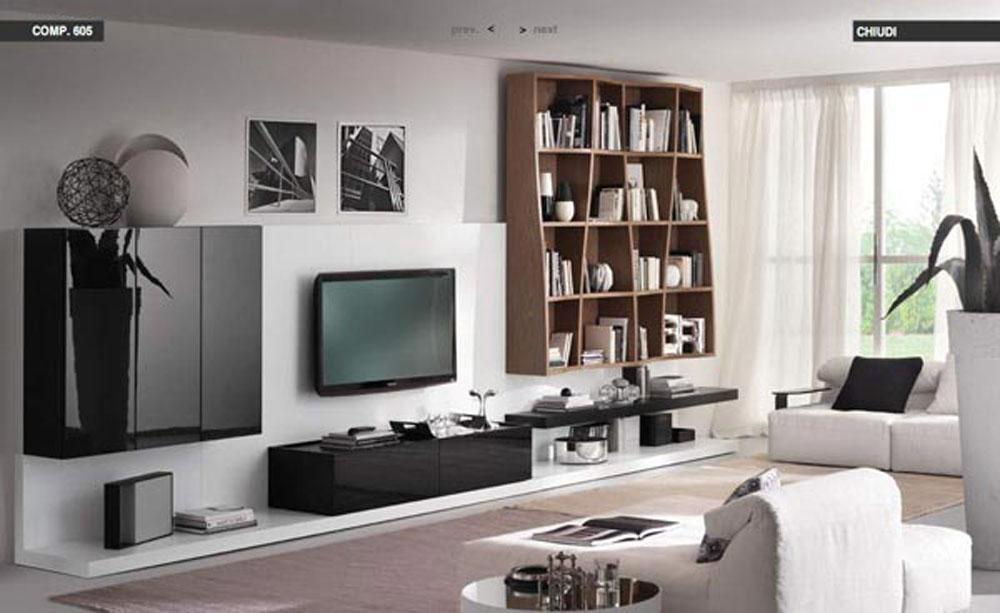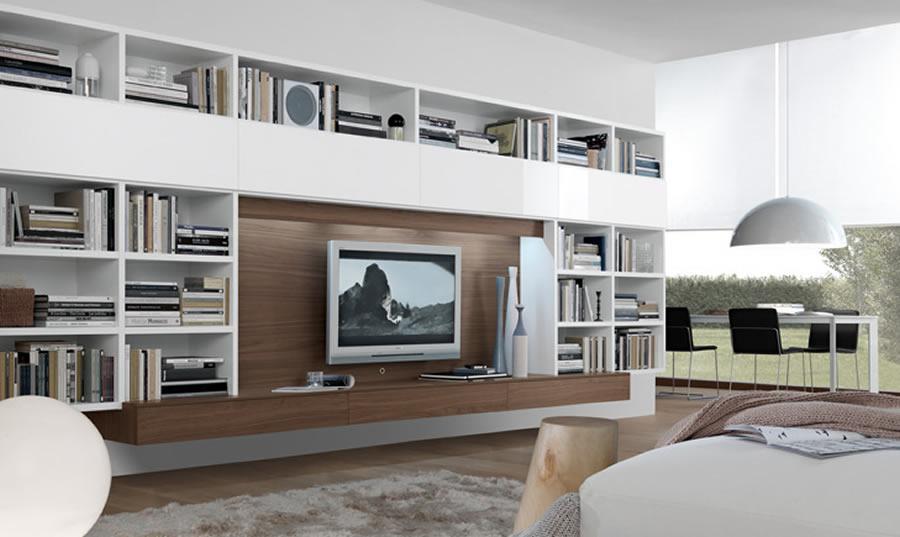The first image is the image on the left, the second image is the image on the right. Analyze the images presented: Is the assertion "The left image shows an all white bookcase with an open back." valid? Answer yes or no. No. 